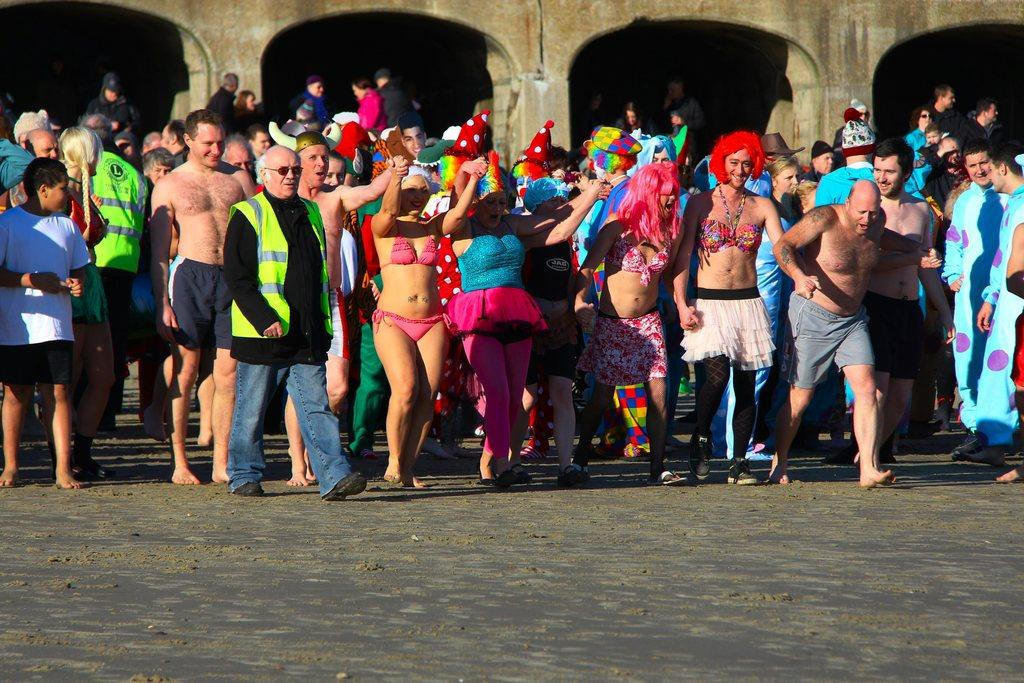What is the main subject of the image? The main subject of the image is a crowd. Can you describe the background of the image? There is a building with arches and pillars in the background. What are some people in the crowd wearing? Some people in the crowd are wearing caps. What flavor of ice cream is being enjoyed by the deer in the image? There are no deer present in the image, and no ice cream is mentioned or visible. 